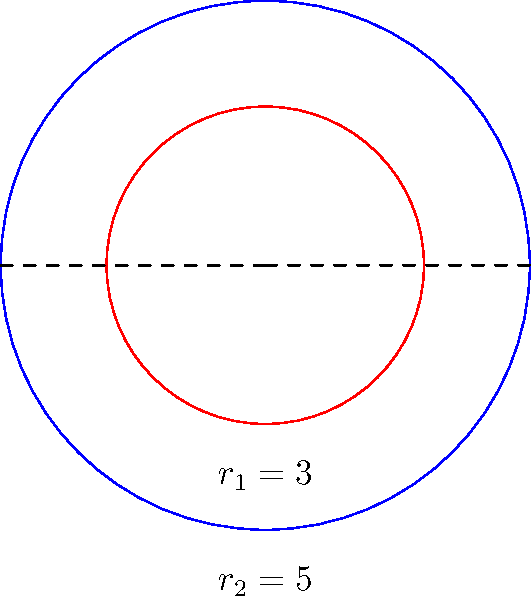In a conflict-affected region of Yemen, a circular safe zone for women's rights activists is established with a radius of 5 km. Within this zone, there's an inner circle with a radius of 3 km designated for secure meeting spaces. What is the area of the region between these two concentric circles, representing the buffer zone for security patrols? Round your answer to the nearest square kilometer. To find the area between two concentric circles, we need to:

1. Calculate the area of the larger circle (safe zone)
2. Calculate the area of the smaller circle (meeting spaces)
3. Subtract the smaller area from the larger area

Step 1: Area of the larger circle
$$A_1 = \pi r_1^2 = \pi (5^2) = 25\pi \approx 78.54 \text{ km}^2$$

Step 2: Area of the smaller circle
$$A_2 = \pi r_2^2 = \pi (3^2) = 9\pi \approx 28.27 \text{ km}^2$$

Step 3: Area of the region between circles
$$A = A_1 - A_2 = 25\pi - 9\pi = 16\pi \approx 50.27 \text{ km}^2$$

Rounding to the nearest square kilometer:
$$50.27 \text{ km}^2 \approx 50 \text{ km}^2$$
Answer: 50 km² 